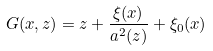Convert formula to latex. <formula><loc_0><loc_0><loc_500><loc_500>G ( x , z ) = z + \frac { \xi ( x ) } { a ^ { 2 } ( z ) } + \xi _ { 0 } ( x )</formula> 